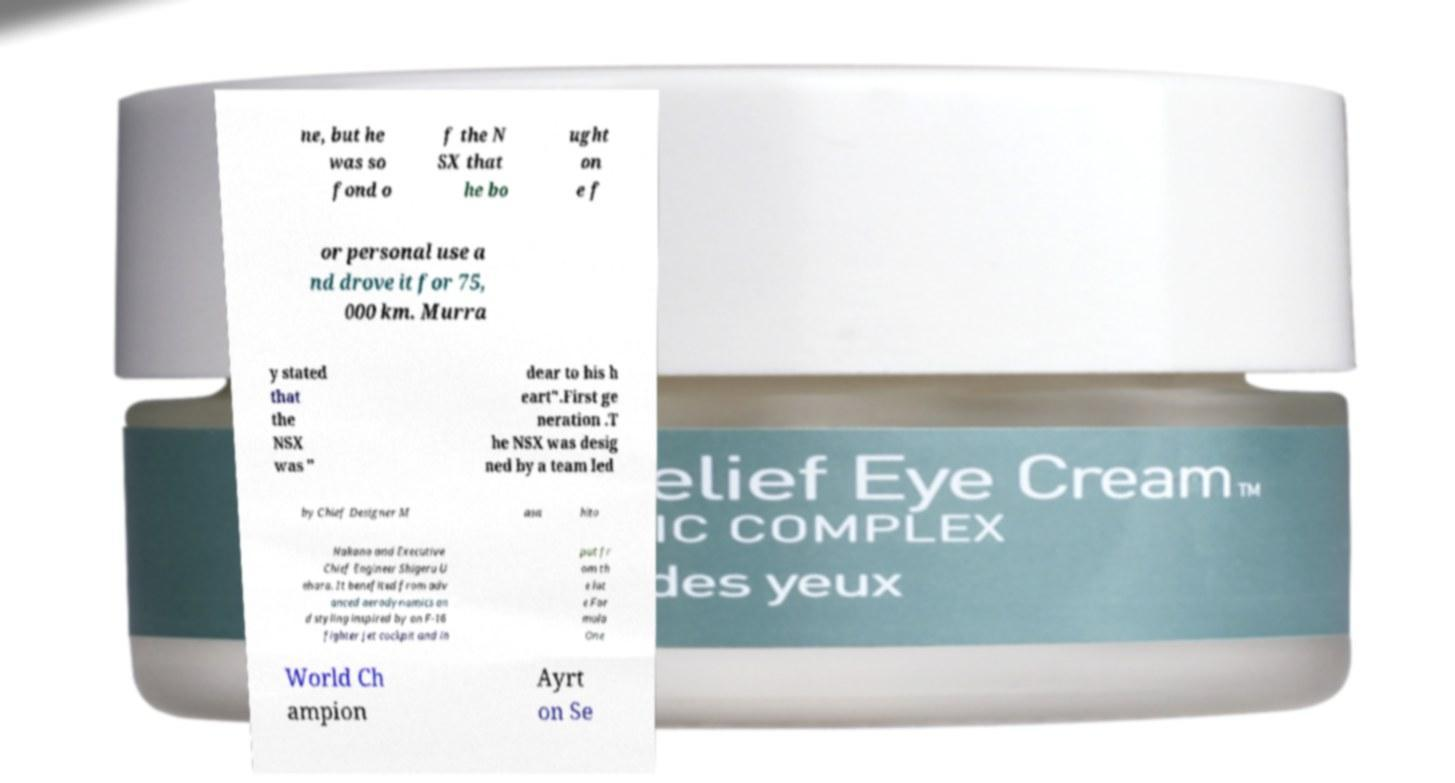Please identify and transcribe the text found in this image. ne, but he was so fond o f the N SX that he bo ught on e f or personal use a nd drove it for 75, 000 km. Murra y stated that the NSX was " dear to his h eart".First ge neration .T he NSX was desig ned by a team led by Chief Designer M asa hito Nakano and Executive Chief Engineer Shigeru U ehara. It benefited from adv anced aerodynamics an d styling inspired by an F-16 fighter jet cockpit and in put fr om th e lat e For mula One World Ch ampion Ayrt on Se 